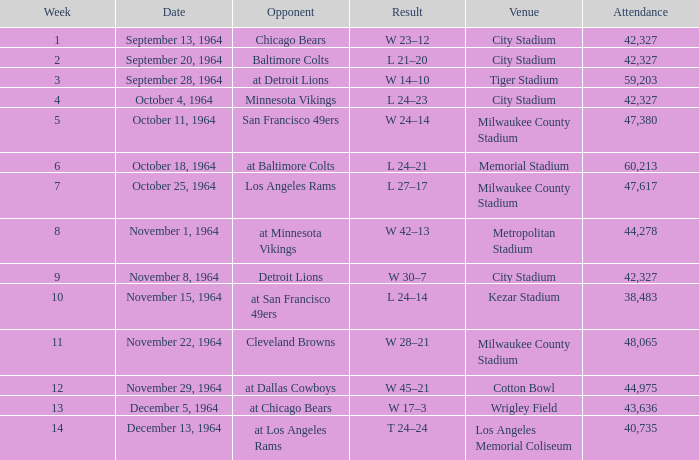During week 4, what is the usual attendance at a game? 42327.0. 